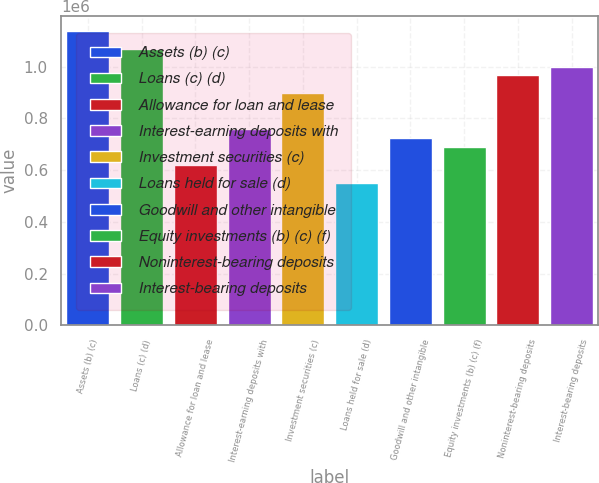Convert chart to OTSL. <chart><loc_0><loc_0><loc_500><loc_500><bar_chart><fcel>Assets (b) (c)<fcel>Loans (c) (d)<fcel>Allowance for loan and lease<fcel>Interest-earning deposits with<fcel>Investment securities (c)<fcel>Loans held for sale (d)<fcel>Goodwill and other intangible<fcel>Equity investments (b) (c) (f)<fcel>Noninterest-bearing deposits<fcel>Interest-bearing deposits<nl><fcel>1.13873e+06<fcel>1.06972e+06<fcel>621129<fcel>759157<fcel>897185<fcel>552114<fcel>724650<fcel>690143<fcel>966199<fcel>1.00071e+06<nl></chart> 